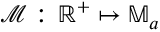<formula> <loc_0><loc_0><loc_500><loc_500>\mathcal { M } \colon \, \mathbb { R } ^ { + } \mapsto \mathbb { M } _ { a }</formula> 